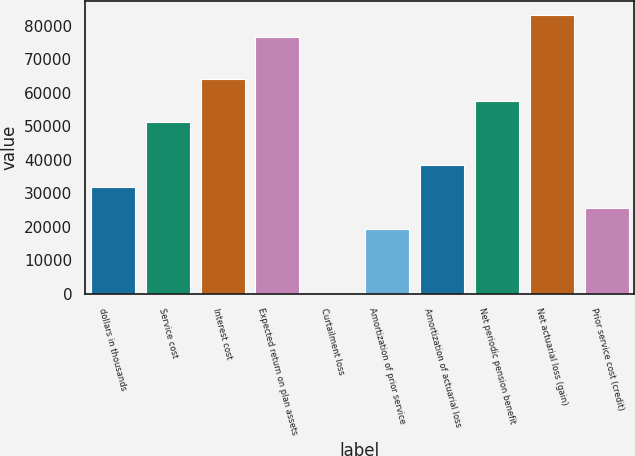Convert chart to OTSL. <chart><loc_0><loc_0><loc_500><loc_500><bar_chart><fcel>dollars in thousands<fcel>Service cost<fcel>Interest cost<fcel>Expected return on plan assets<fcel>Curtailment loss<fcel>Amortization of prior service<fcel>Amortization of actuarial loss<fcel>Net periodic pension benefit<fcel>Net actuarial loss (gain)<fcel>Prior service cost (credit)<nl><fcel>31992.2<fcel>51185.5<fcel>63981<fcel>76776.5<fcel>3.5<fcel>19196.8<fcel>38390<fcel>57583.2<fcel>83174.2<fcel>25594.5<nl></chart> 